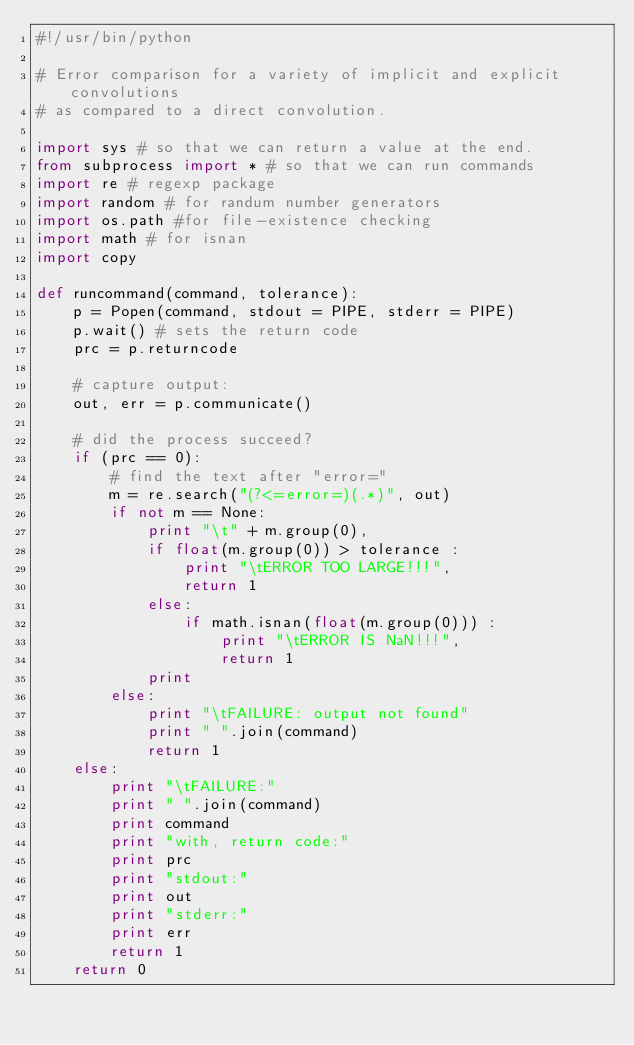Convert code to text. <code><loc_0><loc_0><loc_500><loc_500><_Python_>#!/usr/bin/python

# Error comparison for a variety of implicit and explicit convolutions
# as compared to a direct convolution.

import sys # so that we can return a value at the end.
from subprocess import * # so that we can run commands
import re # regexp package
import random # for randum number generators
import os.path #for file-existence checking
import math # for isnan
import copy

def runcommand(command, tolerance):
    p = Popen(command, stdout = PIPE, stderr = PIPE)
    p.wait() # sets the return code
    prc = p.returncode
    
    # capture output:
    out, err = p.communicate() 

    # did the process succeed?
    if (prc == 0): 
        # find the text after "error="
        m = re.search("(?<=error=)(.*)", out) 
        if not m == None:
            print "\t" + m.group(0),
            if float(m.group(0)) > tolerance :
                print "\tERROR TOO LARGE!!!",
                return 1
            else:
                if math.isnan(float(m.group(0))) :
                    print "\tERROR IS NaN!!!",
                    return 1
            print
        else:
            print "\tFAILURE: output not found"
            print " ".join(command)
            return 1
    else:
        print "\tFAILURE:"
        print " ".join(command)
        print command
        print "with, return code:"
        print prc
        print "stdout:"
        print out
        print "stderr:"
        print err
        return 1
    return 0
</code> 